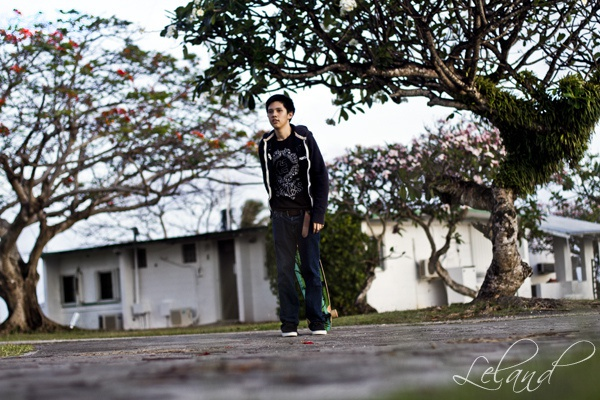Describe the objects in this image and their specific colors. I can see people in white, black, gray, darkgray, and lightgray tones and skateboard in white, black, darkgreen, and gray tones in this image. 